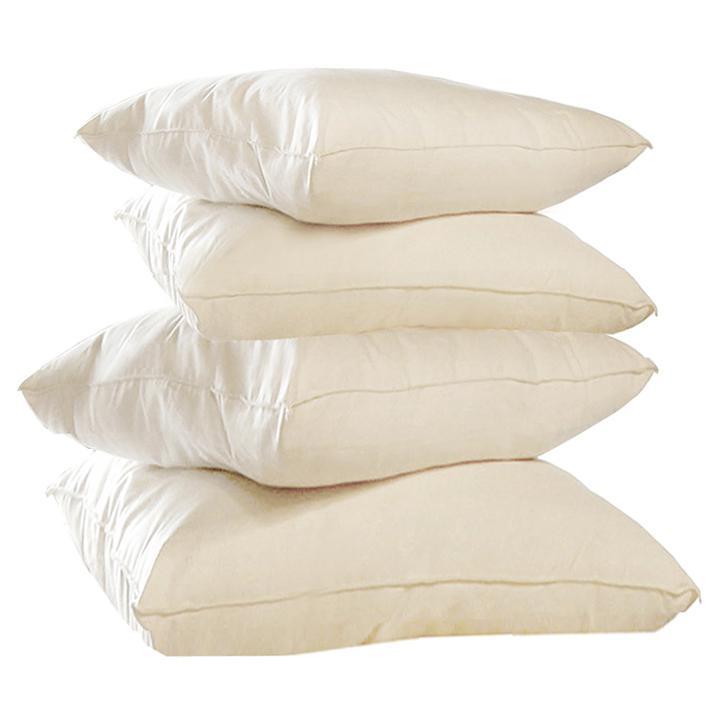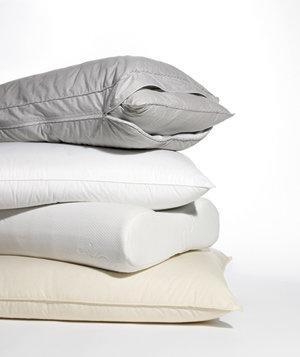The first image is the image on the left, the second image is the image on the right. Analyze the images presented: Is the assertion "There are four pillows stacked up in the image on the left." valid? Answer yes or no. Yes. 